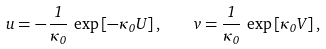<formula> <loc_0><loc_0><loc_500><loc_500>u = - \, \frac { 1 } { \kappa _ { 0 } } \, \exp \left [ - \kappa _ { 0 } U \right ] , \quad v = \frac { 1 } { \kappa _ { 0 } } \, \exp \left [ \kappa _ { 0 } V \right ] ,</formula> 